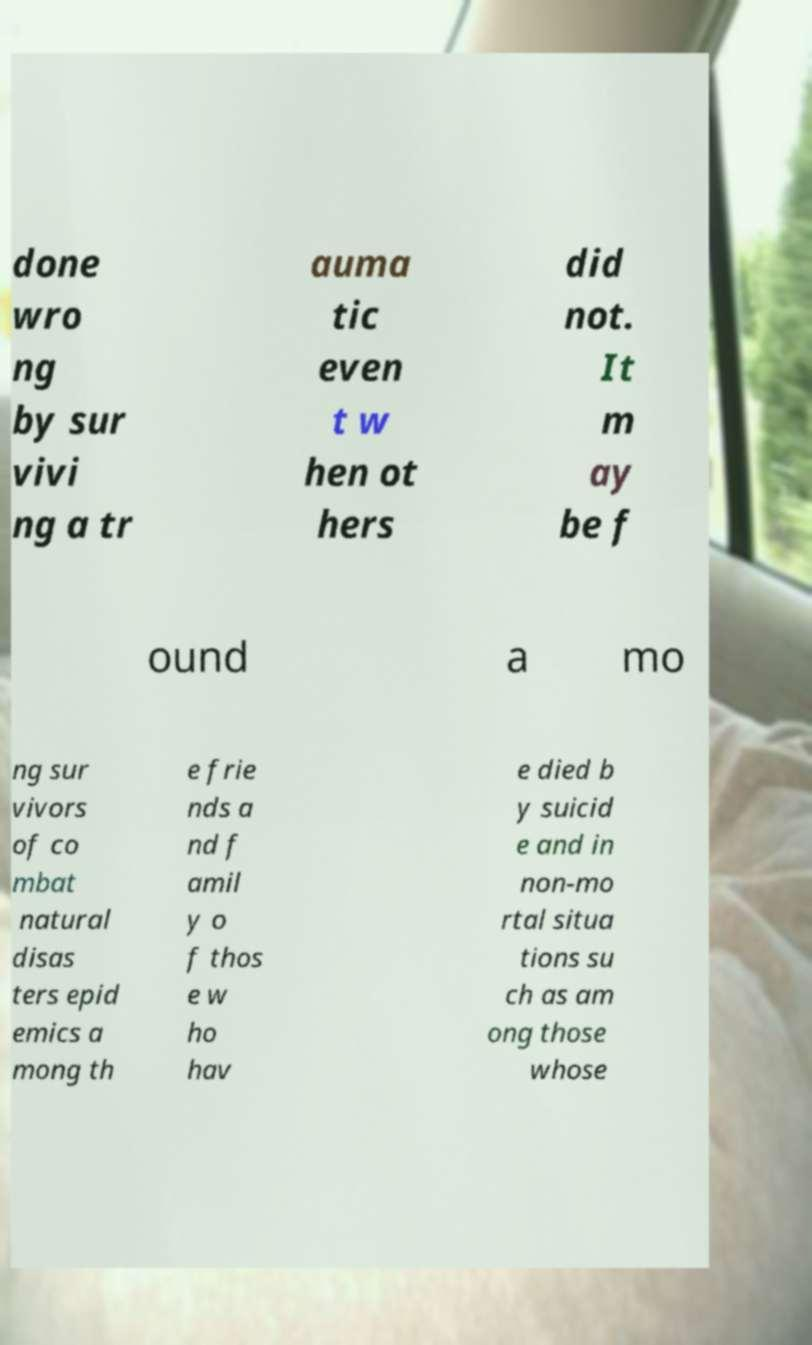Please identify and transcribe the text found in this image. done wro ng by sur vivi ng a tr auma tic even t w hen ot hers did not. It m ay be f ound a mo ng sur vivors of co mbat natural disas ters epid emics a mong th e frie nds a nd f amil y o f thos e w ho hav e died b y suicid e and in non-mo rtal situa tions su ch as am ong those whose 